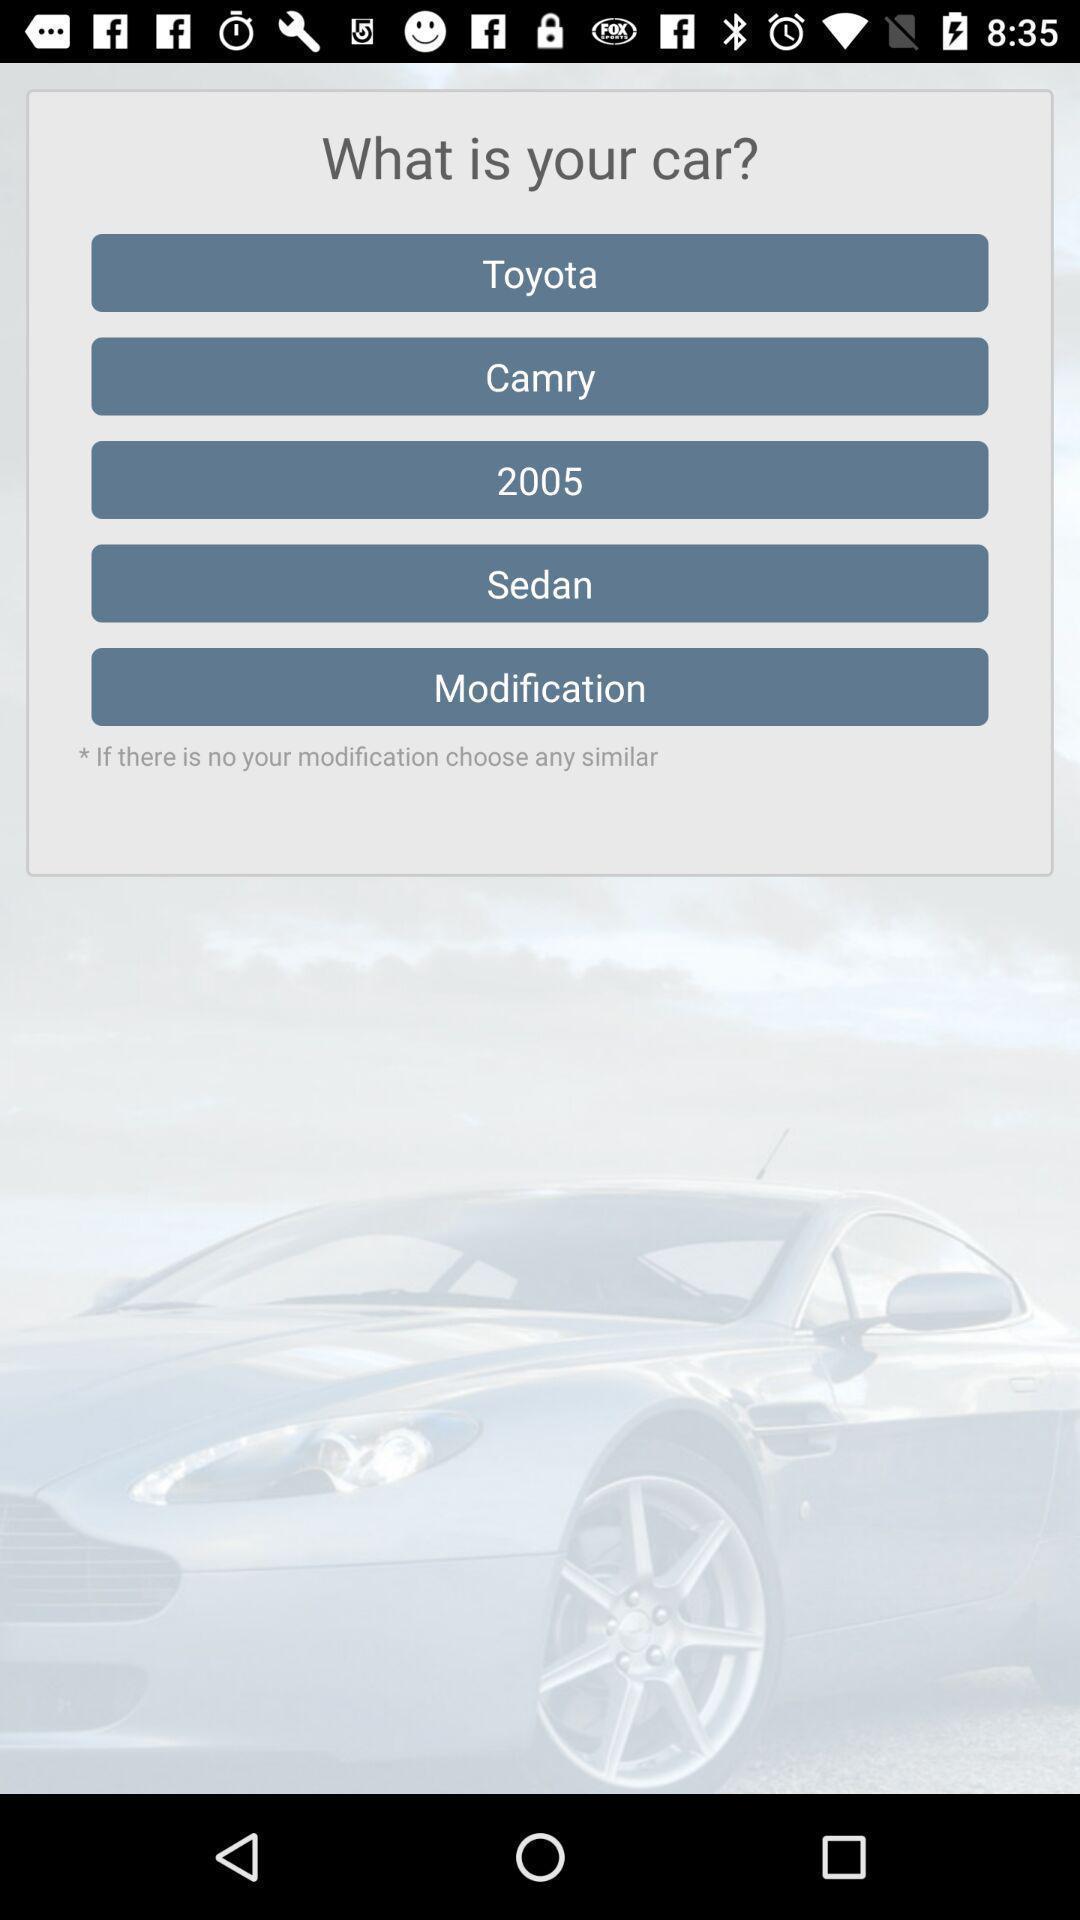Explain the elements present in this screenshot. Screen displaying the details of a car. 